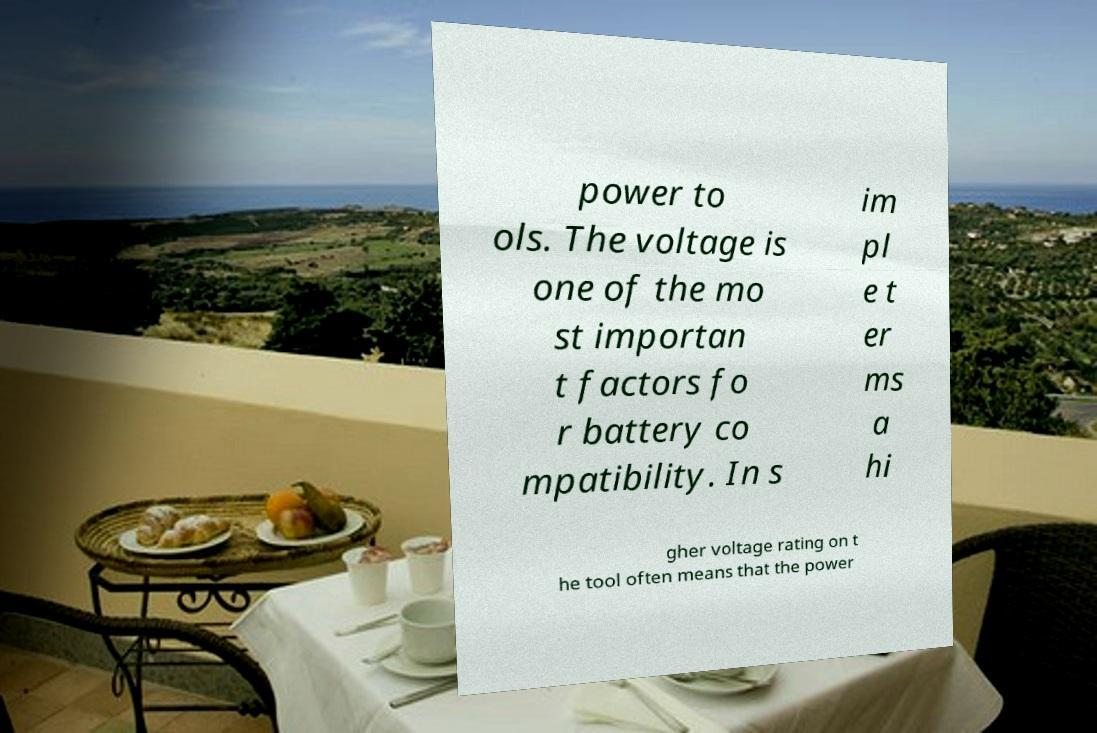Please identify and transcribe the text found in this image. power to ols. The voltage is one of the mo st importan t factors fo r battery co mpatibility. In s im pl e t er ms a hi gher voltage rating on t he tool often means that the power 